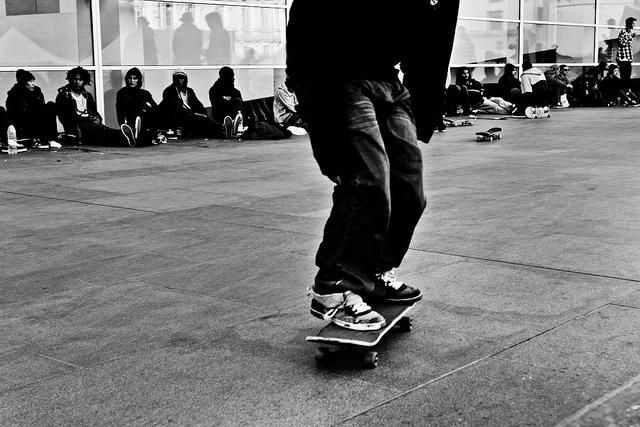What kind of shoes are these?
Short answer required. Sneakers. Is this inside or out?
Answer briefly. Out. Is this an indoor setting?
Give a very brief answer. No. Are all the people in the background waiting their turn to skateboard?
Be succinct. Yes. Where is the young man skateboarding?
Write a very short answer. Sidewalk. 